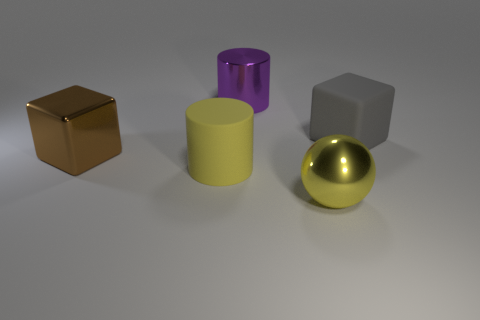The large shiny object that is the same color as the matte cylinder is what shape?
Your answer should be very brief. Sphere. What number of blue metal objects have the same size as the matte cylinder?
Offer a terse response. 0. How many cyan objects are big matte balls or big metal objects?
Make the answer very short. 0. What shape is the big object that is behind the matte object behind the big brown metallic thing?
Offer a terse response. Cylinder. The brown metallic thing that is the same size as the gray matte object is what shape?
Your answer should be compact. Cube. Are there any big rubber things that have the same color as the large shiny cylinder?
Offer a terse response. No. Is the number of matte things that are in front of the gray rubber block the same as the number of balls that are behind the metallic block?
Give a very brief answer. No. There is a large yellow shiny thing; does it have the same shape as the large matte thing that is to the left of the big yellow metal object?
Keep it short and to the point. No. How many other things are made of the same material as the large gray cube?
Ensure brevity in your answer.  1. Are there any yellow metallic balls in front of the gray block?
Make the answer very short. Yes. 